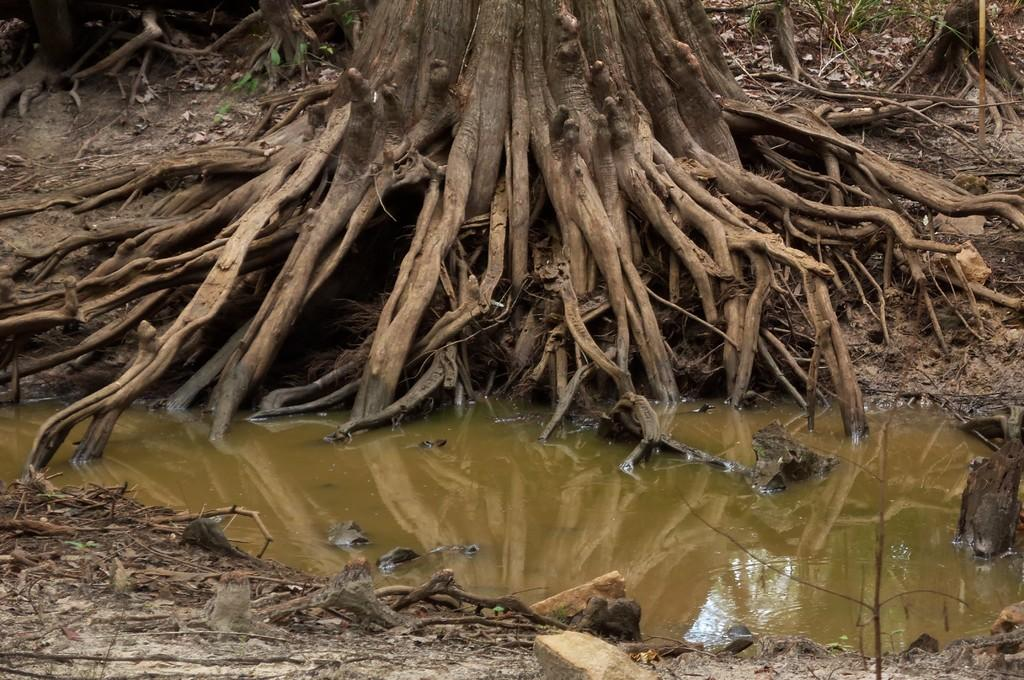What part of a tree can be seen in the image? The roots of a tree are visible in the image. What else can be seen at the bottom of the image? There is water visible at the bottom of the image. What type of plant material is present in the image? Twigs are present in the image. What type of feeling can be seen in the image? There is no feeling present in the image; it contains the roots of a tree, water, and twigs. 